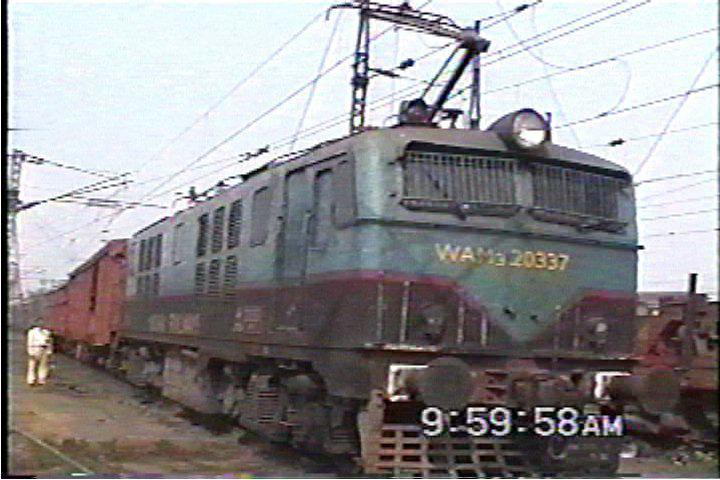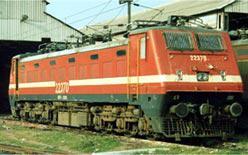The first image is the image on the left, the second image is the image on the right. Analyze the images presented: Is the assertion "The red locomotive is pulling other train cars on the railroad tracks." valid? Answer yes or no. No. The first image is the image on the left, the second image is the image on the right. For the images displayed, is the sentence "Two trains are heading toward the right." factually correct? Answer yes or no. Yes. 